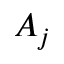Convert formula to latex. <formula><loc_0><loc_0><loc_500><loc_500>A _ { j }</formula> 